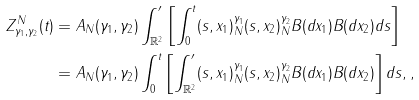<formula> <loc_0><loc_0><loc_500><loc_500>Z _ { \gamma _ { 1 } , \gamma _ { 2 } } ^ { N } ( t ) & = A _ { N } ( \gamma _ { 1 } , \gamma _ { 2 } ) \int _ { \mathbb { R } ^ { 2 } } ^ { \prime } \left [ \int _ { 0 } ^ { t } ( s , x _ { 1 } ) _ { N } ^ { \gamma _ { 1 } } ( s , x _ { 2 } ) _ { N } ^ { \gamma _ { 2 } } B ( d x _ { 1 } ) B ( d x _ { 2 } ) d s \right ] \\ & = A _ { N } ( \gamma _ { 1 } , \gamma _ { 2 } ) \int _ { 0 } ^ { t } \left [ \int _ { \mathbb { R } ^ { 2 } } ^ { \prime } ( s , x _ { 1 } ) _ { N } ^ { \gamma _ { 1 } } ( s , x _ { 2 } ) _ { N } ^ { \gamma _ { 2 } } B ( d x _ { 1 } ) B ( d x _ { 2 } ) \right ] d s , ,</formula> 